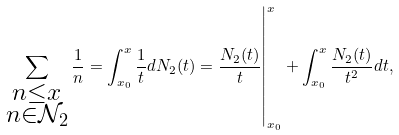Convert formula to latex. <formula><loc_0><loc_0><loc_500><loc_500>\left . \sum _ { \substack { n \leq x \\ n \in \mathcal { N } _ { 2 } } } \frac { 1 } { n } = \int _ { x _ { 0 } } ^ { x } \frac { 1 } { t } d N _ { 2 } ( t ) = \frac { N _ { 2 } ( t ) } { t } \right | _ { x _ { 0 } } ^ { x } + \int _ { x _ { 0 } } ^ { x } \frac { N _ { 2 } ( t ) } { t ^ { 2 } } d t ,</formula> 